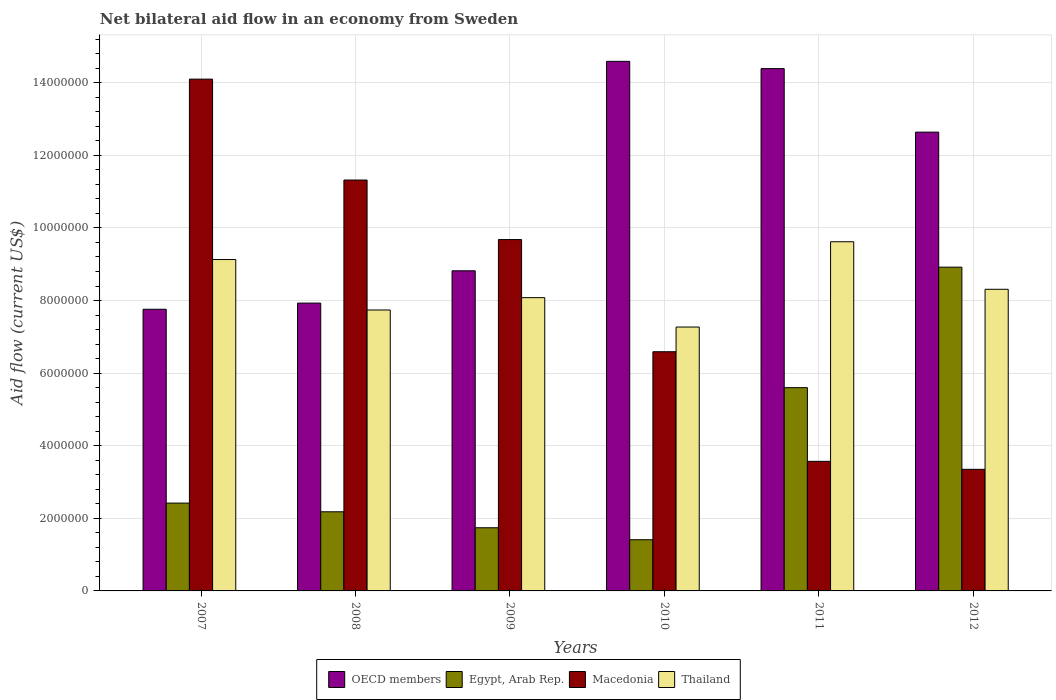Are the number of bars per tick equal to the number of legend labels?
Your response must be concise. Yes. Are the number of bars on each tick of the X-axis equal?
Keep it short and to the point. Yes. How many bars are there on the 3rd tick from the left?
Your answer should be compact. 4. How many bars are there on the 2nd tick from the right?
Provide a short and direct response. 4. What is the net bilateral aid flow in OECD members in 2010?
Make the answer very short. 1.46e+07. Across all years, what is the maximum net bilateral aid flow in Egypt, Arab Rep.?
Provide a short and direct response. 8.92e+06. Across all years, what is the minimum net bilateral aid flow in Macedonia?
Your response must be concise. 3.35e+06. In which year was the net bilateral aid flow in Egypt, Arab Rep. maximum?
Give a very brief answer. 2012. In which year was the net bilateral aid flow in Thailand minimum?
Provide a short and direct response. 2010. What is the total net bilateral aid flow in OECD members in the graph?
Your response must be concise. 6.61e+07. What is the difference between the net bilateral aid flow in Macedonia in 2007 and that in 2009?
Provide a short and direct response. 4.42e+06. What is the difference between the net bilateral aid flow in Egypt, Arab Rep. in 2008 and the net bilateral aid flow in Thailand in 2012?
Provide a succinct answer. -6.13e+06. What is the average net bilateral aid flow in Egypt, Arab Rep. per year?
Ensure brevity in your answer.  3.71e+06. In the year 2012, what is the difference between the net bilateral aid flow in OECD members and net bilateral aid flow in Thailand?
Your response must be concise. 4.33e+06. What is the ratio of the net bilateral aid flow in Egypt, Arab Rep. in 2007 to that in 2008?
Offer a terse response. 1.11. What is the difference between the highest and the second highest net bilateral aid flow in Thailand?
Offer a terse response. 4.90e+05. What is the difference between the highest and the lowest net bilateral aid flow in Egypt, Arab Rep.?
Your response must be concise. 7.51e+06. In how many years, is the net bilateral aid flow in Macedonia greater than the average net bilateral aid flow in Macedonia taken over all years?
Make the answer very short. 3. Is the sum of the net bilateral aid flow in Macedonia in 2009 and 2011 greater than the maximum net bilateral aid flow in OECD members across all years?
Offer a very short reply. No. Is it the case that in every year, the sum of the net bilateral aid flow in OECD members and net bilateral aid flow in Egypt, Arab Rep. is greater than the sum of net bilateral aid flow in Macedonia and net bilateral aid flow in Thailand?
Your answer should be compact. No. What does the 1st bar from the left in 2011 represents?
Your answer should be compact. OECD members. What does the 1st bar from the right in 2009 represents?
Your answer should be very brief. Thailand. Is it the case that in every year, the sum of the net bilateral aid flow in Thailand and net bilateral aid flow in OECD members is greater than the net bilateral aid flow in Egypt, Arab Rep.?
Ensure brevity in your answer.  Yes. How many years are there in the graph?
Keep it short and to the point. 6. What is the difference between two consecutive major ticks on the Y-axis?
Provide a short and direct response. 2.00e+06. Are the values on the major ticks of Y-axis written in scientific E-notation?
Provide a succinct answer. No. Does the graph contain any zero values?
Make the answer very short. No. Where does the legend appear in the graph?
Make the answer very short. Bottom center. How many legend labels are there?
Offer a terse response. 4. How are the legend labels stacked?
Give a very brief answer. Horizontal. What is the title of the graph?
Provide a succinct answer. Net bilateral aid flow in an economy from Sweden. Does "Latin America(all income levels)" appear as one of the legend labels in the graph?
Make the answer very short. No. What is the label or title of the X-axis?
Keep it short and to the point. Years. What is the Aid flow (current US$) of OECD members in 2007?
Your answer should be very brief. 7.76e+06. What is the Aid flow (current US$) in Egypt, Arab Rep. in 2007?
Your answer should be very brief. 2.42e+06. What is the Aid flow (current US$) in Macedonia in 2007?
Your response must be concise. 1.41e+07. What is the Aid flow (current US$) in Thailand in 2007?
Offer a terse response. 9.13e+06. What is the Aid flow (current US$) in OECD members in 2008?
Make the answer very short. 7.93e+06. What is the Aid flow (current US$) in Egypt, Arab Rep. in 2008?
Ensure brevity in your answer.  2.18e+06. What is the Aid flow (current US$) in Macedonia in 2008?
Ensure brevity in your answer.  1.13e+07. What is the Aid flow (current US$) of Thailand in 2008?
Offer a very short reply. 7.74e+06. What is the Aid flow (current US$) in OECD members in 2009?
Offer a terse response. 8.82e+06. What is the Aid flow (current US$) of Egypt, Arab Rep. in 2009?
Give a very brief answer. 1.74e+06. What is the Aid flow (current US$) of Macedonia in 2009?
Your answer should be compact. 9.68e+06. What is the Aid flow (current US$) of Thailand in 2009?
Offer a very short reply. 8.08e+06. What is the Aid flow (current US$) of OECD members in 2010?
Keep it short and to the point. 1.46e+07. What is the Aid flow (current US$) in Egypt, Arab Rep. in 2010?
Offer a very short reply. 1.41e+06. What is the Aid flow (current US$) in Macedonia in 2010?
Give a very brief answer. 6.59e+06. What is the Aid flow (current US$) in Thailand in 2010?
Keep it short and to the point. 7.27e+06. What is the Aid flow (current US$) in OECD members in 2011?
Provide a succinct answer. 1.44e+07. What is the Aid flow (current US$) of Egypt, Arab Rep. in 2011?
Provide a succinct answer. 5.60e+06. What is the Aid flow (current US$) of Macedonia in 2011?
Provide a short and direct response. 3.57e+06. What is the Aid flow (current US$) of Thailand in 2011?
Your response must be concise. 9.62e+06. What is the Aid flow (current US$) of OECD members in 2012?
Offer a terse response. 1.26e+07. What is the Aid flow (current US$) in Egypt, Arab Rep. in 2012?
Ensure brevity in your answer.  8.92e+06. What is the Aid flow (current US$) of Macedonia in 2012?
Make the answer very short. 3.35e+06. What is the Aid flow (current US$) in Thailand in 2012?
Offer a terse response. 8.31e+06. Across all years, what is the maximum Aid flow (current US$) of OECD members?
Give a very brief answer. 1.46e+07. Across all years, what is the maximum Aid flow (current US$) in Egypt, Arab Rep.?
Your answer should be very brief. 8.92e+06. Across all years, what is the maximum Aid flow (current US$) in Macedonia?
Provide a short and direct response. 1.41e+07. Across all years, what is the maximum Aid flow (current US$) of Thailand?
Offer a very short reply. 9.62e+06. Across all years, what is the minimum Aid flow (current US$) of OECD members?
Offer a very short reply. 7.76e+06. Across all years, what is the minimum Aid flow (current US$) in Egypt, Arab Rep.?
Provide a short and direct response. 1.41e+06. Across all years, what is the minimum Aid flow (current US$) in Macedonia?
Give a very brief answer. 3.35e+06. Across all years, what is the minimum Aid flow (current US$) of Thailand?
Provide a succinct answer. 7.27e+06. What is the total Aid flow (current US$) in OECD members in the graph?
Ensure brevity in your answer.  6.61e+07. What is the total Aid flow (current US$) in Egypt, Arab Rep. in the graph?
Offer a very short reply. 2.23e+07. What is the total Aid flow (current US$) in Macedonia in the graph?
Provide a succinct answer. 4.86e+07. What is the total Aid flow (current US$) of Thailand in the graph?
Offer a terse response. 5.02e+07. What is the difference between the Aid flow (current US$) of OECD members in 2007 and that in 2008?
Your response must be concise. -1.70e+05. What is the difference between the Aid flow (current US$) of Egypt, Arab Rep. in 2007 and that in 2008?
Offer a terse response. 2.40e+05. What is the difference between the Aid flow (current US$) in Macedonia in 2007 and that in 2008?
Provide a succinct answer. 2.78e+06. What is the difference between the Aid flow (current US$) in Thailand in 2007 and that in 2008?
Your answer should be compact. 1.39e+06. What is the difference between the Aid flow (current US$) of OECD members in 2007 and that in 2009?
Your answer should be very brief. -1.06e+06. What is the difference between the Aid flow (current US$) of Egypt, Arab Rep. in 2007 and that in 2009?
Provide a short and direct response. 6.80e+05. What is the difference between the Aid flow (current US$) in Macedonia in 2007 and that in 2009?
Keep it short and to the point. 4.42e+06. What is the difference between the Aid flow (current US$) of Thailand in 2007 and that in 2009?
Ensure brevity in your answer.  1.05e+06. What is the difference between the Aid flow (current US$) of OECD members in 2007 and that in 2010?
Your answer should be very brief. -6.83e+06. What is the difference between the Aid flow (current US$) in Egypt, Arab Rep. in 2007 and that in 2010?
Provide a short and direct response. 1.01e+06. What is the difference between the Aid flow (current US$) in Macedonia in 2007 and that in 2010?
Make the answer very short. 7.51e+06. What is the difference between the Aid flow (current US$) in Thailand in 2007 and that in 2010?
Keep it short and to the point. 1.86e+06. What is the difference between the Aid flow (current US$) in OECD members in 2007 and that in 2011?
Your answer should be very brief. -6.63e+06. What is the difference between the Aid flow (current US$) in Egypt, Arab Rep. in 2007 and that in 2011?
Ensure brevity in your answer.  -3.18e+06. What is the difference between the Aid flow (current US$) of Macedonia in 2007 and that in 2011?
Give a very brief answer. 1.05e+07. What is the difference between the Aid flow (current US$) in Thailand in 2007 and that in 2011?
Offer a terse response. -4.90e+05. What is the difference between the Aid flow (current US$) in OECD members in 2007 and that in 2012?
Provide a succinct answer. -4.88e+06. What is the difference between the Aid flow (current US$) in Egypt, Arab Rep. in 2007 and that in 2012?
Your answer should be very brief. -6.50e+06. What is the difference between the Aid flow (current US$) of Macedonia in 2007 and that in 2012?
Provide a succinct answer. 1.08e+07. What is the difference between the Aid flow (current US$) of Thailand in 2007 and that in 2012?
Provide a succinct answer. 8.20e+05. What is the difference between the Aid flow (current US$) in OECD members in 2008 and that in 2009?
Keep it short and to the point. -8.90e+05. What is the difference between the Aid flow (current US$) of Egypt, Arab Rep. in 2008 and that in 2009?
Provide a succinct answer. 4.40e+05. What is the difference between the Aid flow (current US$) of Macedonia in 2008 and that in 2009?
Your answer should be compact. 1.64e+06. What is the difference between the Aid flow (current US$) of OECD members in 2008 and that in 2010?
Offer a very short reply. -6.66e+06. What is the difference between the Aid flow (current US$) of Egypt, Arab Rep. in 2008 and that in 2010?
Give a very brief answer. 7.70e+05. What is the difference between the Aid flow (current US$) in Macedonia in 2008 and that in 2010?
Offer a very short reply. 4.73e+06. What is the difference between the Aid flow (current US$) in OECD members in 2008 and that in 2011?
Offer a very short reply. -6.46e+06. What is the difference between the Aid flow (current US$) in Egypt, Arab Rep. in 2008 and that in 2011?
Your response must be concise. -3.42e+06. What is the difference between the Aid flow (current US$) in Macedonia in 2008 and that in 2011?
Ensure brevity in your answer.  7.75e+06. What is the difference between the Aid flow (current US$) in Thailand in 2008 and that in 2011?
Your answer should be compact. -1.88e+06. What is the difference between the Aid flow (current US$) of OECD members in 2008 and that in 2012?
Make the answer very short. -4.71e+06. What is the difference between the Aid flow (current US$) in Egypt, Arab Rep. in 2008 and that in 2012?
Offer a very short reply. -6.74e+06. What is the difference between the Aid flow (current US$) of Macedonia in 2008 and that in 2012?
Offer a very short reply. 7.97e+06. What is the difference between the Aid flow (current US$) of Thailand in 2008 and that in 2012?
Keep it short and to the point. -5.70e+05. What is the difference between the Aid flow (current US$) in OECD members in 2009 and that in 2010?
Ensure brevity in your answer.  -5.77e+06. What is the difference between the Aid flow (current US$) of Egypt, Arab Rep. in 2009 and that in 2010?
Make the answer very short. 3.30e+05. What is the difference between the Aid flow (current US$) in Macedonia in 2009 and that in 2010?
Offer a very short reply. 3.09e+06. What is the difference between the Aid flow (current US$) in Thailand in 2009 and that in 2010?
Ensure brevity in your answer.  8.10e+05. What is the difference between the Aid flow (current US$) of OECD members in 2009 and that in 2011?
Your response must be concise. -5.57e+06. What is the difference between the Aid flow (current US$) of Egypt, Arab Rep. in 2009 and that in 2011?
Keep it short and to the point. -3.86e+06. What is the difference between the Aid flow (current US$) in Macedonia in 2009 and that in 2011?
Offer a terse response. 6.11e+06. What is the difference between the Aid flow (current US$) of Thailand in 2009 and that in 2011?
Offer a terse response. -1.54e+06. What is the difference between the Aid flow (current US$) of OECD members in 2009 and that in 2012?
Offer a terse response. -3.82e+06. What is the difference between the Aid flow (current US$) of Egypt, Arab Rep. in 2009 and that in 2012?
Offer a very short reply. -7.18e+06. What is the difference between the Aid flow (current US$) of Macedonia in 2009 and that in 2012?
Your response must be concise. 6.33e+06. What is the difference between the Aid flow (current US$) in OECD members in 2010 and that in 2011?
Your response must be concise. 2.00e+05. What is the difference between the Aid flow (current US$) in Egypt, Arab Rep. in 2010 and that in 2011?
Offer a terse response. -4.19e+06. What is the difference between the Aid flow (current US$) in Macedonia in 2010 and that in 2011?
Your response must be concise. 3.02e+06. What is the difference between the Aid flow (current US$) of Thailand in 2010 and that in 2011?
Ensure brevity in your answer.  -2.35e+06. What is the difference between the Aid flow (current US$) in OECD members in 2010 and that in 2012?
Ensure brevity in your answer.  1.95e+06. What is the difference between the Aid flow (current US$) of Egypt, Arab Rep. in 2010 and that in 2012?
Your answer should be very brief. -7.51e+06. What is the difference between the Aid flow (current US$) in Macedonia in 2010 and that in 2012?
Provide a succinct answer. 3.24e+06. What is the difference between the Aid flow (current US$) in Thailand in 2010 and that in 2012?
Ensure brevity in your answer.  -1.04e+06. What is the difference between the Aid flow (current US$) of OECD members in 2011 and that in 2012?
Make the answer very short. 1.75e+06. What is the difference between the Aid flow (current US$) in Egypt, Arab Rep. in 2011 and that in 2012?
Make the answer very short. -3.32e+06. What is the difference between the Aid flow (current US$) in Thailand in 2011 and that in 2012?
Provide a short and direct response. 1.31e+06. What is the difference between the Aid flow (current US$) of OECD members in 2007 and the Aid flow (current US$) of Egypt, Arab Rep. in 2008?
Provide a succinct answer. 5.58e+06. What is the difference between the Aid flow (current US$) of OECD members in 2007 and the Aid flow (current US$) of Macedonia in 2008?
Ensure brevity in your answer.  -3.56e+06. What is the difference between the Aid flow (current US$) of Egypt, Arab Rep. in 2007 and the Aid flow (current US$) of Macedonia in 2008?
Keep it short and to the point. -8.90e+06. What is the difference between the Aid flow (current US$) in Egypt, Arab Rep. in 2007 and the Aid flow (current US$) in Thailand in 2008?
Your response must be concise. -5.32e+06. What is the difference between the Aid flow (current US$) in Macedonia in 2007 and the Aid flow (current US$) in Thailand in 2008?
Your response must be concise. 6.36e+06. What is the difference between the Aid flow (current US$) in OECD members in 2007 and the Aid flow (current US$) in Egypt, Arab Rep. in 2009?
Offer a very short reply. 6.02e+06. What is the difference between the Aid flow (current US$) in OECD members in 2007 and the Aid flow (current US$) in Macedonia in 2009?
Provide a short and direct response. -1.92e+06. What is the difference between the Aid flow (current US$) in OECD members in 2007 and the Aid flow (current US$) in Thailand in 2009?
Give a very brief answer. -3.20e+05. What is the difference between the Aid flow (current US$) in Egypt, Arab Rep. in 2007 and the Aid flow (current US$) in Macedonia in 2009?
Provide a succinct answer. -7.26e+06. What is the difference between the Aid flow (current US$) in Egypt, Arab Rep. in 2007 and the Aid flow (current US$) in Thailand in 2009?
Your answer should be very brief. -5.66e+06. What is the difference between the Aid flow (current US$) of Macedonia in 2007 and the Aid flow (current US$) of Thailand in 2009?
Ensure brevity in your answer.  6.02e+06. What is the difference between the Aid flow (current US$) of OECD members in 2007 and the Aid flow (current US$) of Egypt, Arab Rep. in 2010?
Keep it short and to the point. 6.35e+06. What is the difference between the Aid flow (current US$) of OECD members in 2007 and the Aid flow (current US$) of Macedonia in 2010?
Make the answer very short. 1.17e+06. What is the difference between the Aid flow (current US$) of Egypt, Arab Rep. in 2007 and the Aid flow (current US$) of Macedonia in 2010?
Make the answer very short. -4.17e+06. What is the difference between the Aid flow (current US$) in Egypt, Arab Rep. in 2007 and the Aid flow (current US$) in Thailand in 2010?
Offer a very short reply. -4.85e+06. What is the difference between the Aid flow (current US$) in Macedonia in 2007 and the Aid flow (current US$) in Thailand in 2010?
Keep it short and to the point. 6.83e+06. What is the difference between the Aid flow (current US$) of OECD members in 2007 and the Aid flow (current US$) of Egypt, Arab Rep. in 2011?
Ensure brevity in your answer.  2.16e+06. What is the difference between the Aid flow (current US$) in OECD members in 2007 and the Aid flow (current US$) in Macedonia in 2011?
Offer a very short reply. 4.19e+06. What is the difference between the Aid flow (current US$) of OECD members in 2007 and the Aid flow (current US$) of Thailand in 2011?
Ensure brevity in your answer.  -1.86e+06. What is the difference between the Aid flow (current US$) in Egypt, Arab Rep. in 2007 and the Aid flow (current US$) in Macedonia in 2011?
Offer a very short reply. -1.15e+06. What is the difference between the Aid flow (current US$) of Egypt, Arab Rep. in 2007 and the Aid flow (current US$) of Thailand in 2011?
Provide a short and direct response. -7.20e+06. What is the difference between the Aid flow (current US$) in Macedonia in 2007 and the Aid flow (current US$) in Thailand in 2011?
Your response must be concise. 4.48e+06. What is the difference between the Aid flow (current US$) of OECD members in 2007 and the Aid flow (current US$) of Egypt, Arab Rep. in 2012?
Make the answer very short. -1.16e+06. What is the difference between the Aid flow (current US$) of OECD members in 2007 and the Aid flow (current US$) of Macedonia in 2012?
Keep it short and to the point. 4.41e+06. What is the difference between the Aid flow (current US$) in OECD members in 2007 and the Aid flow (current US$) in Thailand in 2012?
Keep it short and to the point. -5.50e+05. What is the difference between the Aid flow (current US$) of Egypt, Arab Rep. in 2007 and the Aid flow (current US$) of Macedonia in 2012?
Your answer should be very brief. -9.30e+05. What is the difference between the Aid flow (current US$) in Egypt, Arab Rep. in 2007 and the Aid flow (current US$) in Thailand in 2012?
Your answer should be very brief. -5.89e+06. What is the difference between the Aid flow (current US$) of Macedonia in 2007 and the Aid flow (current US$) of Thailand in 2012?
Make the answer very short. 5.79e+06. What is the difference between the Aid flow (current US$) in OECD members in 2008 and the Aid flow (current US$) in Egypt, Arab Rep. in 2009?
Ensure brevity in your answer.  6.19e+06. What is the difference between the Aid flow (current US$) in OECD members in 2008 and the Aid flow (current US$) in Macedonia in 2009?
Make the answer very short. -1.75e+06. What is the difference between the Aid flow (current US$) in Egypt, Arab Rep. in 2008 and the Aid flow (current US$) in Macedonia in 2009?
Ensure brevity in your answer.  -7.50e+06. What is the difference between the Aid flow (current US$) of Egypt, Arab Rep. in 2008 and the Aid flow (current US$) of Thailand in 2009?
Your answer should be very brief. -5.90e+06. What is the difference between the Aid flow (current US$) of Macedonia in 2008 and the Aid flow (current US$) of Thailand in 2009?
Give a very brief answer. 3.24e+06. What is the difference between the Aid flow (current US$) of OECD members in 2008 and the Aid flow (current US$) of Egypt, Arab Rep. in 2010?
Provide a short and direct response. 6.52e+06. What is the difference between the Aid flow (current US$) of OECD members in 2008 and the Aid flow (current US$) of Macedonia in 2010?
Your response must be concise. 1.34e+06. What is the difference between the Aid flow (current US$) of OECD members in 2008 and the Aid flow (current US$) of Thailand in 2010?
Your answer should be compact. 6.60e+05. What is the difference between the Aid flow (current US$) in Egypt, Arab Rep. in 2008 and the Aid flow (current US$) in Macedonia in 2010?
Make the answer very short. -4.41e+06. What is the difference between the Aid flow (current US$) in Egypt, Arab Rep. in 2008 and the Aid flow (current US$) in Thailand in 2010?
Keep it short and to the point. -5.09e+06. What is the difference between the Aid flow (current US$) of Macedonia in 2008 and the Aid flow (current US$) of Thailand in 2010?
Give a very brief answer. 4.05e+06. What is the difference between the Aid flow (current US$) of OECD members in 2008 and the Aid flow (current US$) of Egypt, Arab Rep. in 2011?
Give a very brief answer. 2.33e+06. What is the difference between the Aid flow (current US$) of OECD members in 2008 and the Aid flow (current US$) of Macedonia in 2011?
Provide a succinct answer. 4.36e+06. What is the difference between the Aid flow (current US$) of OECD members in 2008 and the Aid flow (current US$) of Thailand in 2011?
Offer a very short reply. -1.69e+06. What is the difference between the Aid flow (current US$) in Egypt, Arab Rep. in 2008 and the Aid flow (current US$) in Macedonia in 2011?
Offer a terse response. -1.39e+06. What is the difference between the Aid flow (current US$) of Egypt, Arab Rep. in 2008 and the Aid flow (current US$) of Thailand in 2011?
Provide a succinct answer. -7.44e+06. What is the difference between the Aid flow (current US$) in Macedonia in 2008 and the Aid flow (current US$) in Thailand in 2011?
Provide a succinct answer. 1.70e+06. What is the difference between the Aid flow (current US$) in OECD members in 2008 and the Aid flow (current US$) in Egypt, Arab Rep. in 2012?
Provide a short and direct response. -9.90e+05. What is the difference between the Aid flow (current US$) in OECD members in 2008 and the Aid flow (current US$) in Macedonia in 2012?
Ensure brevity in your answer.  4.58e+06. What is the difference between the Aid flow (current US$) of OECD members in 2008 and the Aid flow (current US$) of Thailand in 2012?
Make the answer very short. -3.80e+05. What is the difference between the Aid flow (current US$) of Egypt, Arab Rep. in 2008 and the Aid flow (current US$) of Macedonia in 2012?
Give a very brief answer. -1.17e+06. What is the difference between the Aid flow (current US$) of Egypt, Arab Rep. in 2008 and the Aid flow (current US$) of Thailand in 2012?
Give a very brief answer. -6.13e+06. What is the difference between the Aid flow (current US$) in Macedonia in 2008 and the Aid flow (current US$) in Thailand in 2012?
Your answer should be very brief. 3.01e+06. What is the difference between the Aid flow (current US$) of OECD members in 2009 and the Aid flow (current US$) of Egypt, Arab Rep. in 2010?
Offer a very short reply. 7.41e+06. What is the difference between the Aid flow (current US$) in OECD members in 2009 and the Aid flow (current US$) in Macedonia in 2010?
Your answer should be compact. 2.23e+06. What is the difference between the Aid flow (current US$) of OECD members in 2009 and the Aid flow (current US$) of Thailand in 2010?
Your answer should be very brief. 1.55e+06. What is the difference between the Aid flow (current US$) of Egypt, Arab Rep. in 2009 and the Aid flow (current US$) of Macedonia in 2010?
Give a very brief answer. -4.85e+06. What is the difference between the Aid flow (current US$) of Egypt, Arab Rep. in 2009 and the Aid flow (current US$) of Thailand in 2010?
Offer a terse response. -5.53e+06. What is the difference between the Aid flow (current US$) of Macedonia in 2009 and the Aid flow (current US$) of Thailand in 2010?
Your answer should be compact. 2.41e+06. What is the difference between the Aid flow (current US$) of OECD members in 2009 and the Aid flow (current US$) of Egypt, Arab Rep. in 2011?
Provide a short and direct response. 3.22e+06. What is the difference between the Aid flow (current US$) of OECD members in 2009 and the Aid flow (current US$) of Macedonia in 2011?
Offer a very short reply. 5.25e+06. What is the difference between the Aid flow (current US$) in OECD members in 2009 and the Aid flow (current US$) in Thailand in 2011?
Offer a terse response. -8.00e+05. What is the difference between the Aid flow (current US$) in Egypt, Arab Rep. in 2009 and the Aid flow (current US$) in Macedonia in 2011?
Give a very brief answer. -1.83e+06. What is the difference between the Aid flow (current US$) of Egypt, Arab Rep. in 2009 and the Aid flow (current US$) of Thailand in 2011?
Your response must be concise. -7.88e+06. What is the difference between the Aid flow (current US$) in OECD members in 2009 and the Aid flow (current US$) in Macedonia in 2012?
Keep it short and to the point. 5.47e+06. What is the difference between the Aid flow (current US$) in OECD members in 2009 and the Aid flow (current US$) in Thailand in 2012?
Provide a short and direct response. 5.10e+05. What is the difference between the Aid flow (current US$) of Egypt, Arab Rep. in 2009 and the Aid flow (current US$) of Macedonia in 2012?
Provide a short and direct response. -1.61e+06. What is the difference between the Aid flow (current US$) in Egypt, Arab Rep. in 2009 and the Aid flow (current US$) in Thailand in 2012?
Keep it short and to the point. -6.57e+06. What is the difference between the Aid flow (current US$) in Macedonia in 2009 and the Aid flow (current US$) in Thailand in 2012?
Keep it short and to the point. 1.37e+06. What is the difference between the Aid flow (current US$) of OECD members in 2010 and the Aid flow (current US$) of Egypt, Arab Rep. in 2011?
Make the answer very short. 8.99e+06. What is the difference between the Aid flow (current US$) of OECD members in 2010 and the Aid flow (current US$) of Macedonia in 2011?
Provide a short and direct response. 1.10e+07. What is the difference between the Aid flow (current US$) of OECD members in 2010 and the Aid flow (current US$) of Thailand in 2011?
Offer a terse response. 4.97e+06. What is the difference between the Aid flow (current US$) of Egypt, Arab Rep. in 2010 and the Aid flow (current US$) of Macedonia in 2011?
Provide a succinct answer. -2.16e+06. What is the difference between the Aid flow (current US$) of Egypt, Arab Rep. in 2010 and the Aid flow (current US$) of Thailand in 2011?
Your answer should be compact. -8.21e+06. What is the difference between the Aid flow (current US$) in Macedonia in 2010 and the Aid flow (current US$) in Thailand in 2011?
Provide a short and direct response. -3.03e+06. What is the difference between the Aid flow (current US$) of OECD members in 2010 and the Aid flow (current US$) of Egypt, Arab Rep. in 2012?
Give a very brief answer. 5.67e+06. What is the difference between the Aid flow (current US$) in OECD members in 2010 and the Aid flow (current US$) in Macedonia in 2012?
Offer a terse response. 1.12e+07. What is the difference between the Aid flow (current US$) of OECD members in 2010 and the Aid flow (current US$) of Thailand in 2012?
Provide a succinct answer. 6.28e+06. What is the difference between the Aid flow (current US$) of Egypt, Arab Rep. in 2010 and the Aid flow (current US$) of Macedonia in 2012?
Ensure brevity in your answer.  -1.94e+06. What is the difference between the Aid flow (current US$) in Egypt, Arab Rep. in 2010 and the Aid flow (current US$) in Thailand in 2012?
Offer a terse response. -6.90e+06. What is the difference between the Aid flow (current US$) of Macedonia in 2010 and the Aid flow (current US$) of Thailand in 2012?
Offer a very short reply. -1.72e+06. What is the difference between the Aid flow (current US$) in OECD members in 2011 and the Aid flow (current US$) in Egypt, Arab Rep. in 2012?
Give a very brief answer. 5.47e+06. What is the difference between the Aid flow (current US$) of OECD members in 2011 and the Aid flow (current US$) of Macedonia in 2012?
Provide a short and direct response. 1.10e+07. What is the difference between the Aid flow (current US$) of OECD members in 2011 and the Aid flow (current US$) of Thailand in 2012?
Give a very brief answer. 6.08e+06. What is the difference between the Aid flow (current US$) of Egypt, Arab Rep. in 2011 and the Aid flow (current US$) of Macedonia in 2012?
Your answer should be very brief. 2.25e+06. What is the difference between the Aid flow (current US$) of Egypt, Arab Rep. in 2011 and the Aid flow (current US$) of Thailand in 2012?
Provide a short and direct response. -2.71e+06. What is the difference between the Aid flow (current US$) of Macedonia in 2011 and the Aid flow (current US$) of Thailand in 2012?
Ensure brevity in your answer.  -4.74e+06. What is the average Aid flow (current US$) in OECD members per year?
Provide a short and direct response. 1.10e+07. What is the average Aid flow (current US$) in Egypt, Arab Rep. per year?
Provide a short and direct response. 3.71e+06. What is the average Aid flow (current US$) in Macedonia per year?
Offer a terse response. 8.10e+06. What is the average Aid flow (current US$) in Thailand per year?
Your response must be concise. 8.36e+06. In the year 2007, what is the difference between the Aid flow (current US$) in OECD members and Aid flow (current US$) in Egypt, Arab Rep.?
Offer a very short reply. 5.34e+06. In the year 2007, what is the difference between the Aid flow (current US$) of OECD members and Aid flow (current US$) of Macedonia?
Give a very brief answer. -6.34e+06. In the year 2007, what is the difference between the Aid flow (current US$) of OECD members and Aid flow (current US$) of Thailand?
Your answer should be compact. -1.37e+06. In the year 2007, what is the difference between the Aid flow (current US$) of Egypt, Arab Rep. and Aid flow (current US$) of Macedonia?
Provide a short and direct response. -1.17e+07. In the year 2007, what is the difference between the Aid flow (current US$) in Egypt, Arab Rep. and Aid flow (current US$) in Thailand?
Make the answer very short. -6.71e+06. In the year 2007, what is the difference between the Aid flow (current US$) in Macedonia and Aid flow (current US$) in Thailand?
Give a very brief answer. 4.97e+06. In the year 2008, what is the difference between the Aid flow (current US$) in OECD members and Aid flow (current US$) in Egypt, Arab Rep.?
Your response must be concise. 5.75e+06. In the year 2008, what is the difference between the Aid flow (current US$) in OECD members and Aid flow (current US$) in Macedonia?
Your answer should be compact. -3.39e+06. In the year 2008, what is the difference between the Aid flow (current US$) of Egypt, Arab Rep. and Aid flow (current US$) of Macedonia?
Provide a succinct answer. -9.14e+06. In the year 2008, what is the difference between the Aid flow (current US$) of Egypt, Arab Rep. and Aid flow (current US$) of Thailand?
Your answer should be very brief. -5.56e+06. In the year 2008, what is the difference between the Aid flow (current US$) of Macedonia and Aid flow (current US$) of Thailand?
Give a very brief answer. 3.58e+06. In the year 2009, what is the difference between the Aid flow (current US$) of OECD members and Aid flow (current US$) of Egypt, Arab Rep.?
Give a very brief answer. 7.08e+06. In the year 2009, what is the difference between the Aid flow (current US$) of OECD members and Aid flow (current US$) of Macedonia?
Offer a terse response. -8.60e+05. In the year 2009, what is the difference between the Aid flow (current US$) in OECD members and Aid flow (current US$) in Thailand?
Give a very brief answer. 7.40e+05. In the year 2009, what is the difference between the Aid flow (current US$) in Egypt, Arab Rep. and Aid flow (current US$) in Macedonia?
Offer a terse response. -7.94e+06. In the year 2009, what is the difference between the Aid flow (current US$) in Egypt, Arab Rep. and Aid flow (current US$) in Thailand?
Make the answer very short. -6.34e+06. In the year 2009, what is the difference between the Aid flow (current US$) of Macedonia and Aid flow (current US$) of Thailand?
Offer a terse response. 1.60e+06. In the year 2010, what is the difference between the Aid flow (current US$) in OECD members and Aid flow (current US$) in Egypt, Arab Rep.?
Your answer should be compact. 1.32e+07. In the year 2010, what is the difference between the Aid flow (current US$) in OECD members and Aid flow (current US$) in Macedonia?
Provide a short and direct response. 8.00e+06. In the year 2010, what is the difference between the Aid flow (current US$) in OECD members and Aid flow (current US$) in Thailand?
Your answer should be compact. 7.32e+06. In the year 2010, what is the difference between the Aid flow (current US$) in Egypt, Arab Rep. and Aid flow (current US$) in Macedonia?
Keep it short and to the point. -5.18e+06. In the year 2010, what is the difference between the Aid flow (current US$) in Egypt, Arab Rep. and Aid flow (current US$) in Thailand?
Offer a very short reply. -5.86e+06. In the year 2010, what is the difference between the Aid flow (current US$) in Macedonia and Aid flow (current US$) in Thailand?
Ensure brevity in your answer.  -6.80e+05. In the year 2011, what is the difference between the Aid flow (current US$) of OECD members and Aid flow (current US$) of Egypt, Arab Rep.?
Make the answer very short. 8.79e+06. In the year 2011, what is the difference between the Aid flow (current US$) in OECD members and Aid flow (current US$) in Macedonia?
Offer a very short reply. 1.08e+07. In the year 2011, what is the difference between the Aid flow (current US$) of OECD members and Aid flow (current US$) of Thailand?
Keep it short and to the point. 4.77e+06. In the year 2011, what is the difference between the Aid flow (current US$) of Egypt, Arab Rep. and Aid flow (current US$) of Macedonia?
Offer a very short reply. 2.03e+06. In the year 2011, what is the difference between the Aid flow (current US$) of Egypt, Arab Rep. and Aid flow (current US$) of Thailand?
Keep it short and to the point. -4.02e+06. In the year 2011, what is the difference between the Aid flow (current US$) in Macedonia and Aid flow (current US$) in Thailand?
Provide a succinct answer. -6.05e+06. In the year 2012, what is the difference between the Aid flow (current US$) in OECD members and Aid flow (current US$) in Egypt, Arab Rep.?
Provide a short and direct response. 3.72e+06. In the year 2012, what is the difference between the Aid flow (current US$) in OECD members and Aid flow (current US$) in Macedonia?
Your answer should be very brief. 9.29e+06. In the year 2012, what is the difference between the Aid flow (current US$) in OECD members and Aid flow (current US$) in Thailand?
Give a very brief answer. 4.33e+06. In the year 2012, what is the difference between the Aid flow (current US$) of Egypt, Arab Rep. and Aid flow (current US$) of Macedonia?
Provide a short and direct response. 5.57e+06. In the year 2012, what is the difference between the Aid flow (current US$) in Macedonia and Aid flow (current US$) in Thailand?
Your response must be concise. -4.96e+06. What is the ratio of the Aid flow (current US$) of OECD members in 2007 to that in 2008?
Give a very brief answer. 0.98. What is the ratio of the Aid flow (current US$) of Egypt, Arab Rep. in 2007 to that in 2008?
Provide a short and direct response. 1.11. What is the ratio of the Aid flow (current US$) of Macedonia in 2007 to that in 2008?
Offer a very short reply. 1.25. What is the ratio of the Aid flow (current US$) in Thailand in 2007 to that in 2008?
Make the answer very short. 1.18. What is the ratio of the Aid flow (current US$) of OECD members in 2007 to that in 2009?
Your answer should be very brief. 0.88. What is the ratio of the Aid flow (current US$) of Egypt, Arab Rep. in 2007 to that in 2009?
Your response must be concise. 1.39. What is the ratio of the Aid flow (current US$) of Macedonia in 2007 to that in 2009?
Offer a terse response. 1.46. What is the ratio of the Aid flow (current US$) of Thailand in 2007 to that in 2009?
Ensure brevity in your answer.  1.13. What is the ratio of the Aid flow (current US$) in OECD members in 2007 to that in 2010?
Offer a very short reply. 0.53. What is the ratio of the Aid flow (current US$) of Egypt, Arab Rep. in 2007 to that in 2010?
Your response must be concise. 1.72. What is the ratio of the Aid flow (current US$) in Macedonia in 2007 to that in 2010?
Offer a terse response. 2.14. What is the ratio of the Aid flow (current US$) of Thailand in 2007 to that in 2010?
Make the answer very short. 1.26. What is the ratio of the Aid flow (current US$) of OECD members in 2007 to that in 2011?
Offer a terse response. 0.54. What is the ratio of the Aid flow (current US$) of Egypt, Arab Rep. in 2007 to that in 2011?
Keep it short and to the point. 0.43. What is the ratio of the Aid flow (current US$) of Macedonia in 2007 to that in 2011?
Your answer should be very brief. 3.95. What is the ratio of the Aid flow (current US$) of Thailand in 2007 to that in 2011?
Provide a succinct answer. 0.95. What is the ratio of the Aid flow (current US$) in OECD members in 2007 to that in 2012?
Make the answer very short. 0.61. What is the ratio of the Aid flow (current US$) in Egypt, Arab Rep. in 2007 to that in 2012?
Your answer should be very brief. 0.27. What is the ratio of the Aid flow (current US$) in Macedonia in 2007 to that in 2012?
Your answer should be very brief. 4.21. What is the ratio of the Aid flow (current US$) in Thailand in 2007 to that in 2012?
Offer a very short reply. 1.1. What is the ratio of the Aid flow (current US$) in OECD members in 2008 to that in 2009?
Give a very brief answer. 0.9. What is the ratio of the Aid flow (current US$) in Egypt, Arab Rep. in 2008 to that in 2009?
Keep it short and to the point. 1.25. What is the ratio of the Aid flow (current US$) in Macedonia in 2008 to that in 2009?
Your answer should be very brief. 1.17. What is the ratio of the Aid flow (current US$) in Thailand in 2008 to that in 2009?
Keep it short and to the point. 0.96. What is the ratio of the Aid flow (current US$) of OECD members in 2008 to that in 2010?
Your answer should be very brief. 0.54. What is the ratio of the Aid flow (current US$) in Egypt, Arab Rep. in 2008 to that in 2010?
Offer a terse response. 1.55. What is the ratio of the Aid flow (current US$) of Macedonia in 2008 to that in 2010?
Offer a terse response. 1.72. What is the ratio of the Aid flow (current US$) in Thailand in 2008 to that in 2010?
Your answer should be compact. 1.06. What is the ratio of the Aid flow (current US$) in OECD members in 2008 to that in 2011?
Offer a terse response. 0.55. What is the ratio of the Aid flow (current US$) in Egypt, Arab Rep. in 2008 to that in 2011?
Your answer should be very brief. 0.39. What is the ratio of the Aid flow (current US$) of Macedonia in 2008 to that in 2011?
Give a very brief answer. 3.17. What is the ratio of the Aid flow (current US$) of Thailand in 2008 to that in 2011?
Give a very brief answer. 0.8. What is the ratio of the Aid flow (current US$) of OECD members in 2008 to that in 2012?
Keep it short and to the point. 0.63. What is the ratio of the Aid flow (current US$) of Egypt, Arab Rep. in 2008 to that in 2012?
Offer a very short reply. 0.24. What is the ratio of the Aid flow (current US$) of Macedonia in 2008 to that in 2012?
Keep it short and to the point. 3.38. What is the ratio of the Aid flow (current US$) in Thailand in 2008 to that in 2012?
Keep it short and to the point. 0.93. What is the ratio of the Aid flow (current US$) of OECD members in 2009 to that in 2010?
Make the answer very short. 0.6. What is the ratio of the Aid flow (current US$) in Egypt, Arab Rep. in 2009 to that in 2010?
Your answer should be compact. 1.23. What is the ratio of the Aid flow (current US$) of Macedonia in 2009 to that in 2010?
Provide a short and direct response. 1.47. What is the ratio of the Aid flow (current US$) of Thailand in 2009 to that in 2010?
Keep it short and to the point. 1.11. What is the ratio of the Aid flow (current US$) in OECD members in 2009 to that in 2011?
Keep it short and to the point. 0.61. What is the ratio of the Aid flow (current US$) in Egypt, Arab Rep. in 2009 to that in 2011?
Your answer should be very brief. 0.31. What is the ratio of the Aid flow (current US$) of Macedonia in 2009 to that in 2011?
Offer a terse response. 2.71. What is the ratio of the Aid flow (current US$) in Thailand in 2009 to that in 2011?
Provide a short and direct response. 0.84. What is the ratio of the Aid flow (current US$) of OECD members in 2009 to that in 2012?
Keep it short and to the point. 0.7. What is the ratio of the Aid flow (current US$) of Egypt, Arab Rep. in 2009 to that in 2012?
Your answer should be compact. 0.2. What is the ratio of the Aid flow (current US$) of Macedonia in 2009 to that in 2012?
Give a very brief answer. 2.89. What is the ratio of the Aid flow (current US$) of Thailand in 2009 to that in 2012?
Offer a terse response. 0.97. What is the ratio of the Aid flow (current US$) of OECD members in 2010 to that in 2011?
Offer a very short reply. 1.01. What is the ratio of the Aid flow (current US$) in Egypt, Arab Rep. in 2010 to that in 2011?
Keep it short and to the point. 0.25. What is the ratio of the Aid flow (current US$) of Macedonia in 2010 to that in 2011?
Offer a very short reply. 1.85. What is the ratio of the Aid flow (current US$) in Thailand in 2010 to that in 2011?
Keep it short and to the point. 0.76. What is the ratio of the Aid flow (current US$) of OECD members in 2010 to that in 2012?
Your response must be concise. 1.15. What is the ratio of the Aid flow (current US$) in Egypt, Arab Rep. in 2010 to that in 2012?
Offer a very short reply. 0.16. What is the ratio of the Aid flow (current US$) in Macedonia in 2010 to that in 2012?
Your response must be concise. 1.97. What is the ratio of the Aid flow (current US$) of Thailand in 2010 to that in 2012?
Your answer should be compact. 0.87. What is the ratio of the Aid flow (current US$) of OECD members in 2011 to that in 2012?
Make the answer very short. 1.14. What is the ratio of the Aid flow (current US$) in Egypt, Arab Rep. in 2011 to that in 2012?
Ensure brevity in your answer.  0.63. What is the ratio of the Aid flow (current US$) of Macedonia in 2011 to that in 2012?
Provide a succinct answer. 1.07. What is the ratio of the Aid flow (current US$) in Thailand in 2011 to that in 2012?
Your answer should be compact. 1.16. What is the difference between the highest and the second highest Aid flow (current US$) in OECD members?
Your answer should be compact. 2.00e+05. What is the difference between the highest and the second highest Aid flow (current US$) of Egypt, Arab Rep.?
Your answer should be compact. 3.32e+06. What is the difference between the highest and the second highest Aid flow (current US$) of Macedonia?
Give a very brief answer. 2.78e+06. What is the difference between the highest and the second highest Aid flow (current US$) of Thailand?
Give a very brief answer. 4.90e+05. What is the difference between the highest and the lowest Aid flow (current US$) in OECD members?
Provide a succinct answer. 6.83e+06. What is the difference between the highest and the lowest Aid flow (current US$) in Egypt, Arab Rep.?
Make the answer very short. 7.51e+06. What is the difference between the highest and the lowest Aid flow (current US$) in Macedonia?
Make the answer very short. 1.08e+07. What is the difference between the highest and the lowest Aid flow (current US$) of Thailand?
Your answer should be compact. 2.35e+06. 